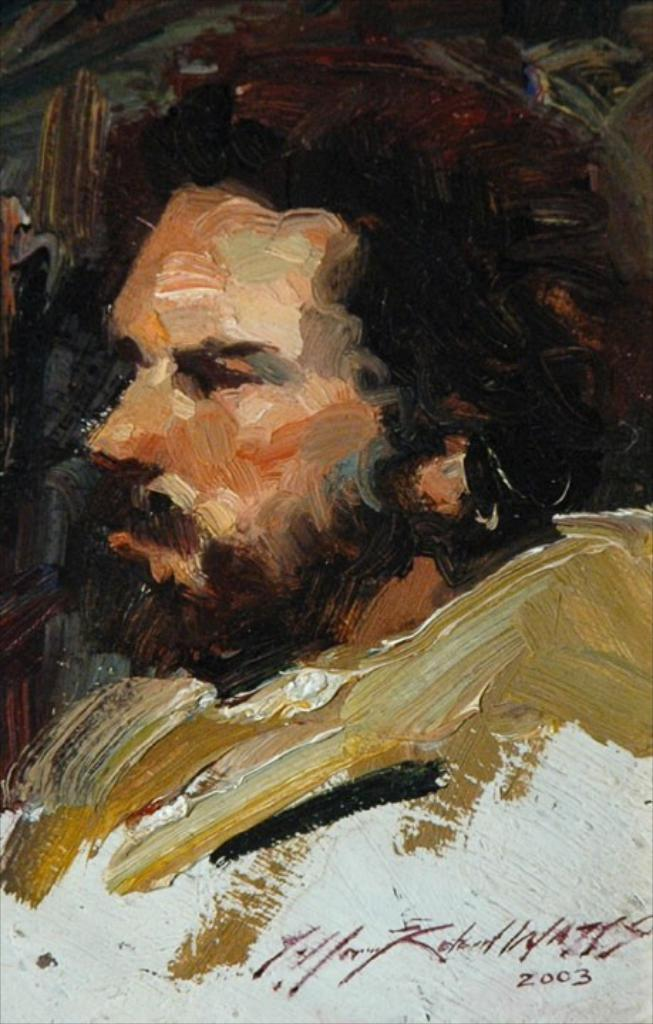What is the main subject of the image? There is a man's painting in the center of the image. Can you describe the painting in more detail? Unfortunately, the facts provided do not give any additional details about the painting. Is there anything else in the image besides the painting? The facts provided do not mention any other elements in the image. What historical event is depicted in the harbor scene in the image? There is no harbor scene or any historical event mentioned in the image. 